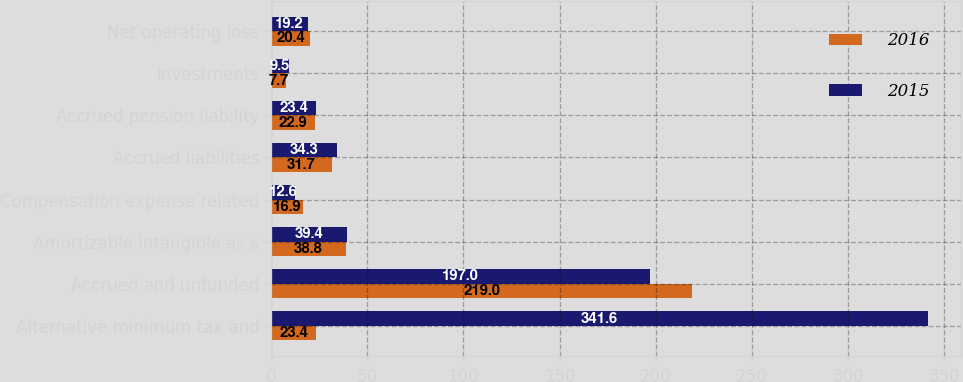Convert chart to OTSL. <chart><loc_0><loc_0><loc_500><loc_500><stacked_bar_chart><ecel><fcel>Alternative minimum tax and<fcel>Accrued and unfunded<fcel>Amortizable intangible as s<fcel>Compensation expense related<fcel>Accrued liabilities<fcel>Accrued pension liability<fcel>Investments<fcel>Net operating loss<nl><fcel>2016<fcel>23.4<fcel>219<fcel>38.8<fcel>16.9<fcel>31.7<fcel>22.9<fcel>7.7<fcel>20.4<nl><fcel>2015<fcel>341.6<fcel>197<fcel>39.4<fcel>12.6<fcel>34.3<fcel>23.4<fcel>9.5<fcel>19.2<nl></chart> 